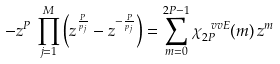Convert formula to latex. <formula><loc_0><loc_0><loc_500><loc_500>- z ^ { P } \, \prod _ { j = 1 } ^ { M } \left ( z ^ { \frac { P } { p _ { j } } } - z ^ { - \frac { P } { p _ { j } } } \right ) = \sum _ { m = 0 } ^ { 2 P - 1 } \chi _ { 2 P } ^ { \ v v { E } } ( m ) \, z ^ { m }</formula> 